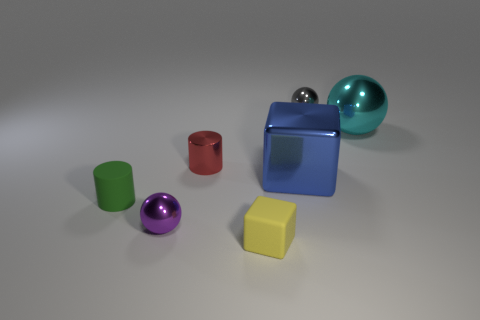Add 1 red things. How many objects exist? 8 Subtract all balls. How many objects are left? 4 Add 6 green matte things. How many green matte things exist? 7 Subtract 0 cyan blocks. How many objects are left? 7 Subtract all big blue metal things. Subtract all purple spheres. How many objects are left? 5 Add 5 shiny spheres. How many shiny spheres are left? 8 